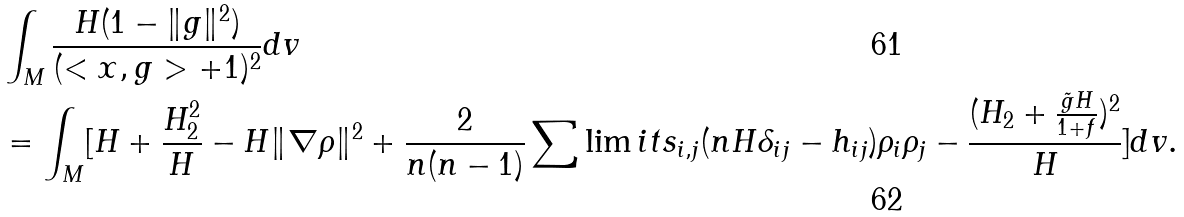<formula> <loc_0><loc_0><loc_500><loc_500>& \int _ { M } \frac { H ( 1 - \| g \| ^ { 2 } ) } { ( < x , g > + 1 ) ^ { 2 } } d v \\ & = \int _ { M } [ H + \frac { H _ { 2 } ^ { 2 } } { H } - H \| \nabla \rho \| ^ { 2 } + \frac { 2 } { n ( n - 1 ) } \sum \lim i t s _ { i , j } ( n H \delta _ { i j } - h _ { i j } ) \rho _ { i } \rho _ { j } - \frac { ( H _ { 2 } + \frac { \tilde { g } H } { 1 + f } ) ^ { 2 } } { H } ] d v .</formula> 